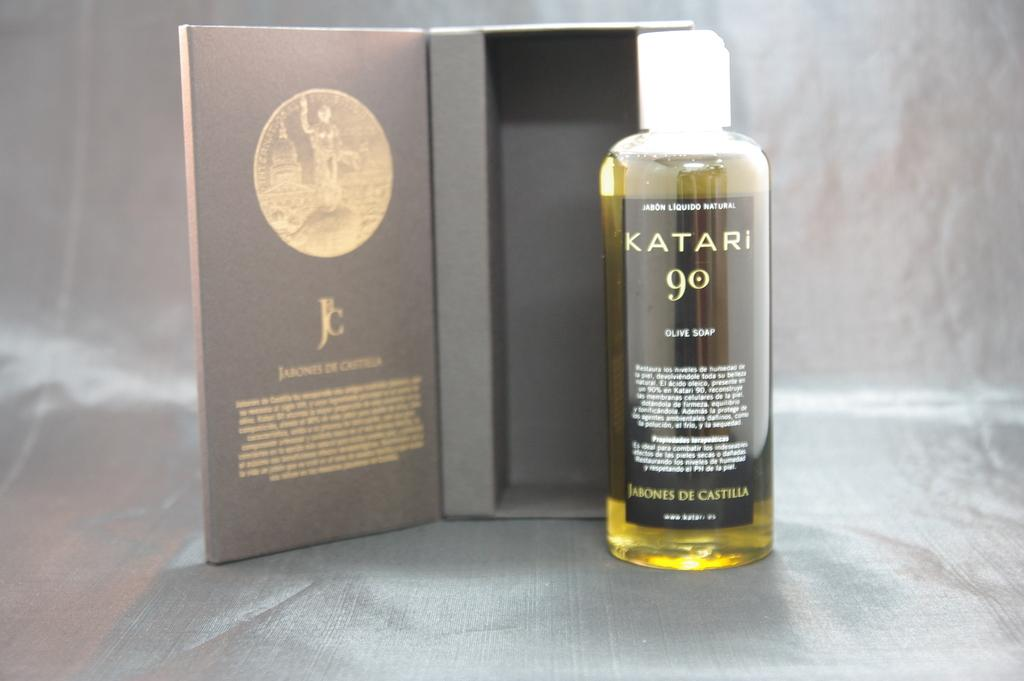<image>
Offer a succinct explanation of the picture presented. A bottle of Katari 90 Olive Soap is displayed next to its box. 